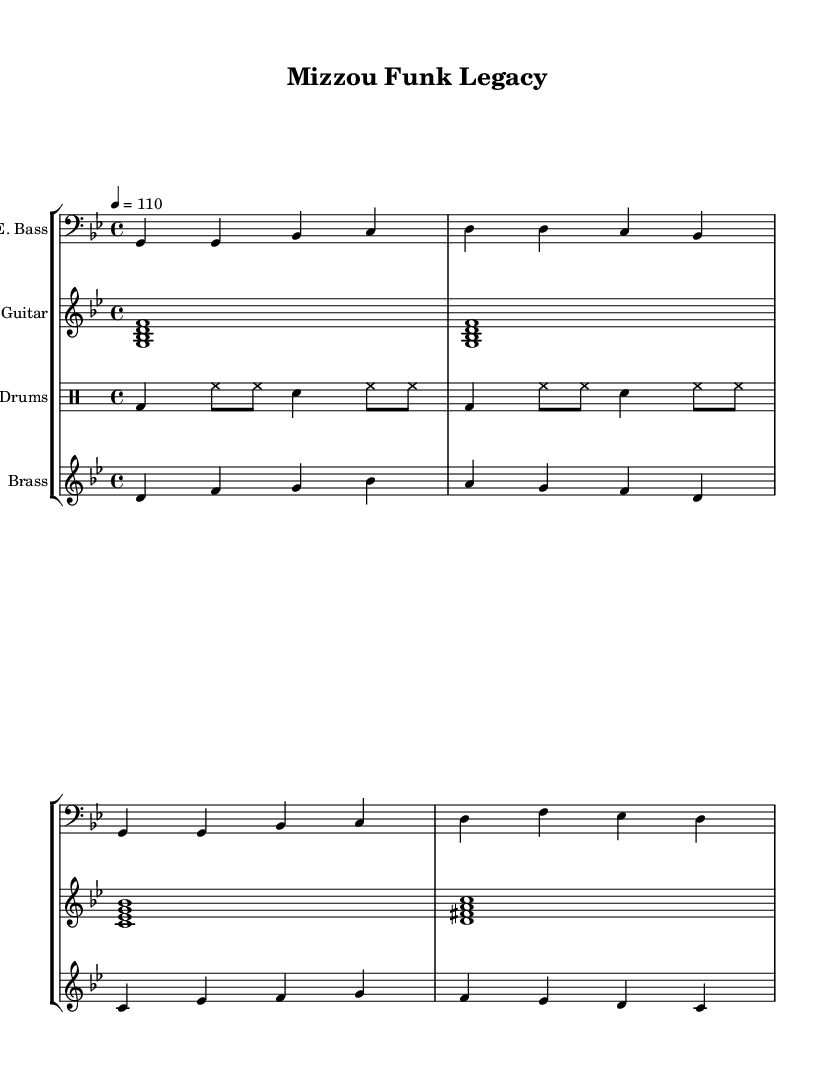What is the key signature of this music? The key signature is G minor, which has two flats (B♭ and E♭) indicated at the beginning of the staff.
Answer: G minor What is the time signature of this music? The time signature is 4/4, which means there are four beats in each measure and the quarter note gets one beat.
Answer: 4/4 What is the tempo marking of this music? The tempo marking is 110 beats per minute, indicating that the piece should be played at a moderate pace.
Answer: 110 What instruments are included in this piece? The instruments listed are electric bass, electric guitar, drums, and brass. These are specified at the beginning of each staff.
Answer: Electric bass, electric guitar, drums, brass Which section has the brass melody? The brass melody can be found in the staff labeled "Brass," where specific notes (D, F, G, B♭) are notated.
Answer: Brass How many measures does the drum pattern consist of? The drum pattern comprises two measures as indicated by the notation that repeats within a single area.
Answer: Two measures What is the first note of the electric bass line? The first note of the electric bass line is G, which is indicated by the first note in the respective staff.
Answer: G 